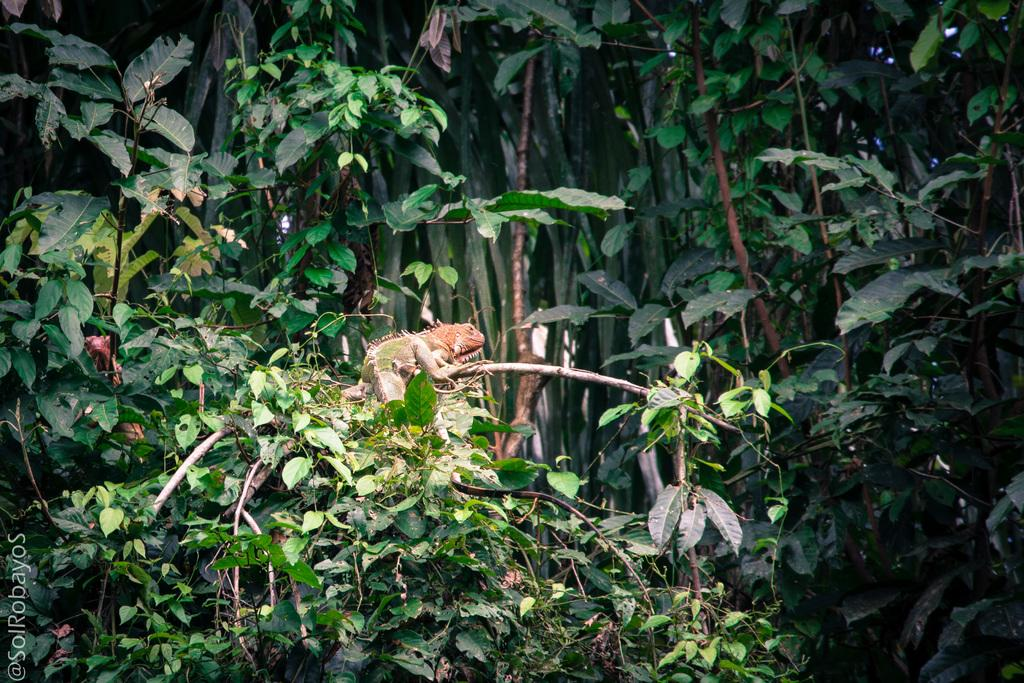What is the main feature of the image? The main feature of the image is the presence of a lot of plants. Can you describe the reptile in the image? There is a reptile on one of the branches of the plants. How many beetles are pushing the fireman in the image? There are no beetles or firemen present in the image. 